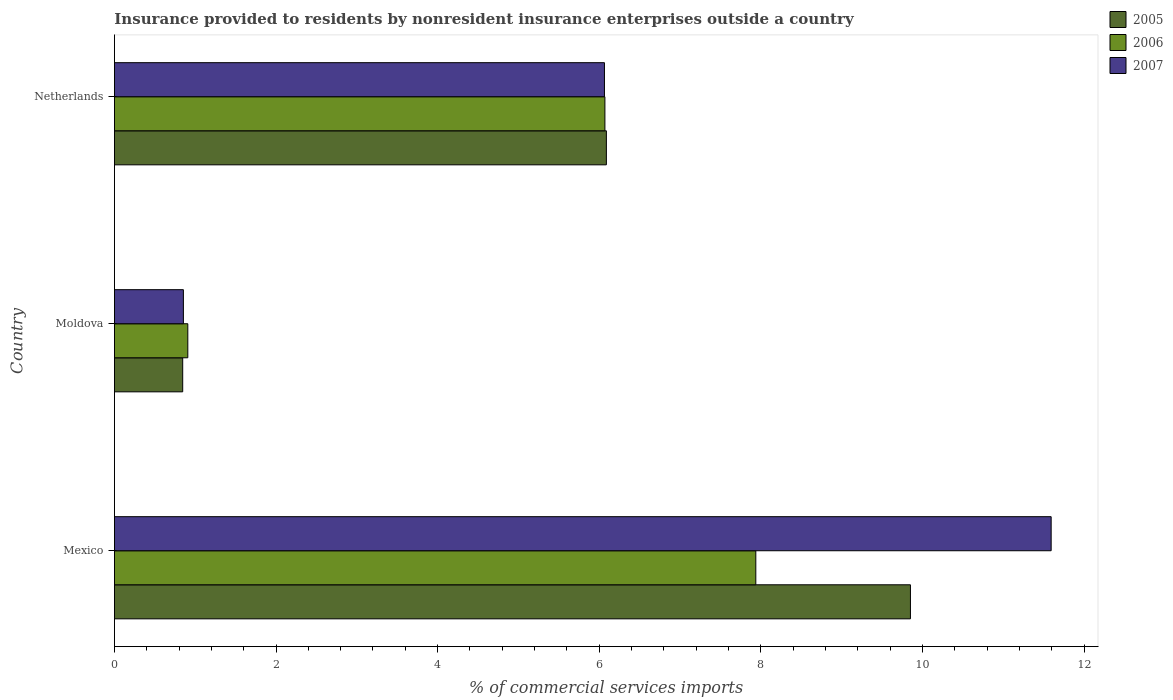How many different coloured bars are there?
Make the answer very short. 3. Are the number of bars per tick equal to the number of legend labels?
Offer a very short reply. Yes. How many bars are there on the 3rd tick from the top?
Make the answer very short. 3. How many bars are there on the 1st tick from the bottom?
Ensure brevity in your answer.  3. What is the label of the 2nd group of bars from the top?
Offer a very short reply. Moldova. In how many cases, is the number of bars for a given country not equal to the number of legend labels?
Make the answer very short. 0. What is the Insurance provided to residents in 2005 in Moldova?
Give a very brief answer. 0.85. Across all countries, what is the maximum Insurance provided to residents in 2005?
Provide a succinct answer. 9.85. Across all countries, what is the minimum Insurance provided to residents in 2006?
Provide a short and direct response. 0.91. In which country was the Insurance provided to residents in 2006 minimum?
Your response must be concise. Moldova. What is the total Insurance provided to residents in 2006 in the graph?
Keep it short and to the point. 14.92. What is the difference between the Insurance provided to residents in 2007 in Moldova and that in Netherlands?
Offer a terse response. -5.21. What is the difference between the Insurance provided to residents in 2007 in Moldova and the Insurance provided to residents in 2006 in Mexico?
Ensure brevity in your answer.  -7.08. What is the average Insurance provided to residents in 2005 per country?
Keep it short and to the point. 5.6. What is the difference between the Insurance provided to residents in 2005 and Insurance provided to residents in 2006 in Mexico?
Give a very brief answer. 1.91. In how many countries, is the Insurance provided to residents in 2005 greater than 10.8 %?
Keep it short and to the point. 0. What is the ratio of the Insurance provided to residents in 2006 in Mexico to that in Moldova?
Offer a terse response. 8.74. Is the Insurance provided to residents in 2007 in Moldova less than that in Netherlands?
Keep it short and to the point. Yes. Is the difference between the Insurance provided to residents in 2005 in Mexico and Netherlands greater than the difference between the Insurance provided to residents in 2006 in Mexico and Netherlands?
Give a very brief answer. Yes. What is the difference between the highest and the second highest Insurance provided to residents in 2005?
Provide a short and direct response. 3.76. What is the difference between the highest and the lowest Insurance provided to residents in 2005?
Offer a terse response. 9.01. Is it the case that in every country, the sum of the Insurance provided to residents in 2007 and Insurance provided to residents in 2006 is greater than the Insurance provided to residents in 2005?
Your answer should be very brief. Yes. Are all the bars in the graph horizontal?
Your answer should be compact. Yes. Are the values on the major ticks of X-axis written in scientific E-notation?
Ensure brevity in your answer.  No. Does the graph contain any zero values?
Make the answer very short. No. Does the graph contain grids?
Give a very brief answer. No. How are the legend labels stacked?
Make the answer very short. Vertical. What is the title of the graph?
Provide a succinct answer. Insurance provided to residents by nonresident insurance enterprises outside a country. Does "1965" appear as one of the legend labels in the graph?
Provide a succinct answer. No. What is the label or title of the X-axis?
Your response must be concise. % of commercial services imports. What is the label or title of the Y-axis?
Your answer should be compact. Country. What is the % of commercial services imports of 2005 in Mexico?
Offer a very short reply. 9.85. What is the % of commercial services imports of 2006 in Mexico?
Offer a very short reply. 7.94. What is the % of commercial services imports of 2007 in Mexico?
Provide a succinct answer. 11.59. What is the % of commercial services imports in 2005 in Moldova?
Your answer should be compact. 0.85. What is the % of commercial services imports of 2006 in Moldova?
Give a very brief answer. 0.91. What is the % of commercial services imports of 2007 in Moldova?
Your answer should be compact. 0.85. What is the % of commercial services imports in 2005 in Netherlands?
Offer a very short reply. 6.09. What is the % of commercial services imports in 2006 in Netherlands?
Offer a terse response. 6.07. What is the % of commercial services imports of 2007 in Netherlands?
Provide a succinct answer. 6.06. Across all countries, what is the maximum % of commercial services imports in 2005?
Make the answer very short. 9.85. Across all countries, what is the maximum % of commercial services imports of 2006?
Your answer should be very brief. 7.94. Across all countries, what is the maximum % of commercial services imports of 2007?
Keep it short and to the point. 11.59. Across all countries, what is the minimum % of commercial services imports of 2005?
Offer a very short reply. 0.85. Across all countries, what is the minimum % of commercial services imports of 2006?
Give a very brief answer. 0.91. Across all countries, what is the minimum % of commercial services imports of 2007?
Offer a terse response. 0.85. What is the total % of commercial services imports in 2005 in the graph?
Ensure brevity in your answer.  16.79. What is the total % of commercial services imports in 2006 in the graph?
Ensure brevity in your answer.  14.92. What is the total % of commercial services imports of 2007 in the graph?
Your response must be concise. 18.51. What is the difference between the % of commercial services imports of 2005 in Mexico and that in Moldova?
Offer a very short reply. 9.01. What is the difference between the % of commercial services imports of 2006 in Mexico and that in Moldova?
Your response must be concise. 7.03. What is the difference between the % of commercial services imports in 2007 in Mexico and that in Moldova?
Provide a succinct answer. 10.74. What is the difference between the % of commercial services imports of 2005 in Mexico and that in Netherlands?
Your response must be concise. 3.76. What is the difference between the % of commercial services imports of 2006 in Mexico and that in Netherlands?
Provide a short and direct response. 1.87. What is the difference between the % of commercial services imports of 2007 in Mexico and that in Netherlands?
Your answer should be very brief. 5.53. What is the difference between the % of commercial services imports in 2005 in Moldova and that in Netherlands?
Provide a succinct answer. -5.24. What is the difference between the % of commercial services imports in 2006 in Moldova and that in Netherlands?
Your answer should be very brief. -5.16. What is the difference between the % of commercial services imports of 2007 in Moldova and that in Netherlands?
Keep it short and to the point. -5.21. What is the difference between the % of commercial services imports of 2005 in Mexico and the % of commercial services imports of 2006 in Moldova?
Your response must be concise. 8.94. What is the difference between the % of commercial services imports of 2005 in Mexico and the % of commercial services imports of 2007 in Moldova?
Provide a short and direct response. 9. What is the difference between the % of commercial services imports in 2006 in Mexico and the % of commercial services imports in 2007 in Moldova?
Make the answer very short. 7.08. What is the difference between the % of commercial services imports of 2005 in Mexico and the % of commercial services imports of 2006 in Netherlands?
Give a very brief answer. 3.78. What is the difference between the % of commercial services imports in 2005 in Mexico and the % of commercial services imports in 2007 in Netherlands?
Provide a short and direct response. 3.79. What is the difference between the % of commercial services imports of 2006 in Mexico and the % of commercial services imports of 2007 in Netherlands?
Your answer should be very brief. 1.87. What is the difference between the % of commercial services imports of 2005 in Moldova and the % of commercial services imports of 2006 in Netherlands?
Your answer should be compact. -5.23. What is the difference between the % of commercial services imports of 2005 in Moldova and the % of commercial services imports of 2007 in Netherlands?
Your answer should be very brief. -5.22. What is the difference between the % of commercial services imports in 2006 in Moldova and the % of commercial services imports in 2007 in Netherlands?
Ensure brevity in your answer.  -5.16. What is the average % of commercial services imports of 2005 per country?
Offer a very short reply. 5.6. What is the average % of commercial services imports of 2006 per country?
Your answer should be compact. 4.97. What is the average % of commercial services imports in 2007 per country?
Provide a succinct answer. 6.17. What is the difference between the % of commercial services imports of 2005 and % of commercial services imports of 2006 in Mexico?
Provide a short and direct response. 1.91. What is the difference between the % of commercial services imports of 2005 and % of commercial services imports of 2007 in Mexico?
Provide a short and direct response. -1.74. What is the difference between the % of commercial services imports of 2006 and % of commercial services imports of 2007 in Mexico?
Your response must be concise. -3.66. What is the difference between the % of commercial services imports of 2005 and % of commercial services imports of 2006 in Moldova?
Your answer should be compact. -0.06. What is the difference between the % of commercial services imports of 2005 and % of commercial services imports of 2007 in Moldova?
Your answer should be compact. -0.01. What is the difference between the % of commercial services imports in 2006 and % of commercial services imports in 2007 in Moldova?
Ensure brevity in your answer.  0.05. What is the difference between the % of commercial services imports in 2005 and % of commercial services imports in 2006 in Netherlands?
Offer a terse response. 0.02. What is the difference between the % of commercial services imports of 2005 and % of commercial services imports of 2007 in Netherlands?
Your answer should be compact. 0.02. What is the difference between the % of commercial services imports in 2006 and % of commercial services imports in 2007 in Netherlands?
Ensure brevity in your answer.  0.01. What is the ratio of the % of commercial services imports in 2005 in Mexico to that in Moldova?
Offer a very short reply. 11.66. What is the ratio of the % of commercial services imports in 2006 in Mexico to that in Moldova?
Provide a succinct answer. 8.74. What is the ratio of the % of commercial services imports in 2007 in Mexico to that in Moldova?
Make the answer very short. 13.58. What is the ratio of the % of commercial services imports in 2005 in Mexico to that in Netherlands?
Make the answer very short. 1.62. What is the ratio of the % of commercial services imports in 2006 in Mexico to that in Netherlands?
Make the answer very short. 1.31. What is the ratio of the % of commercial services imports of 2007 in Mexico to that in Netherlands?
Give a very brief answer. 1.91. What is the ratio of the % of commercial services imports of 2005 in Moldova to that in Netherlands?
Your answer should be compact. 0.14. What is the ratio of the % of commercial services imports of 2006 in Moldova to that in Netherlands?
Keep it short and to the point. 0.15. What is the ratio of the % of commercial services imports in 2007 in Moldova to that in Netherlands?
Make the answer very short. 0.14. What is the difference between the highest and the second highest % of commercial services imports in 2005?
Your response must be concise. 3.76. What is the difference between the highest and the second highest % of commercial services imports of 2006?
Offer a terse response. 1.87. What is the difference between the highest and the second highest % of commercial services imports of 2007?
Give a very brief answer. 5.53. What is the difference between the highest and the lowest % of commercial services imports in 2005?
Keep it short and to the point. 9.01. What is the difference between the highest and the lowest % of commercial services imports of 2006?
Ensure brevity in your answer.  7.03. What is the difference between the highest and the lowest % of commercial services imports of 2007?
Keep it short and to the point. 10.74. 